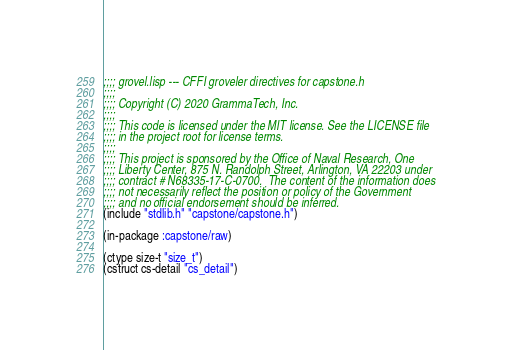<code> <loc_0><loc_0><loc_500><loc_500><_Lisp_>;;;; grovel.lisp --- CFFI groveler directives for capstone.h
;;;;
;;;; Copyright (C) 2020 GrammaTech, Inc.
;;;;
;;;; This code is licensed under the MIT license. See the LICENSE file
;;;; in the project root for license terms.
;;;;
;;;; This project is sponsored by the Office of Naval Research, One
;;;; Liberty Center, 875 N. Randolph Street, Arlington, VA 22203 under
;;;; contract # N68335-17-C-0700.  The content of the information does
;;;; not necessarily reflect the position or policy of the Government
;;;; and no official endorsement should be inferred.
(include "stdlib.h" "capstone/capstone.h")

(in-package :capstone/raw)

(ctype size-t "size_t")
(cstruct cs-detail "cs_detail")
</code> 